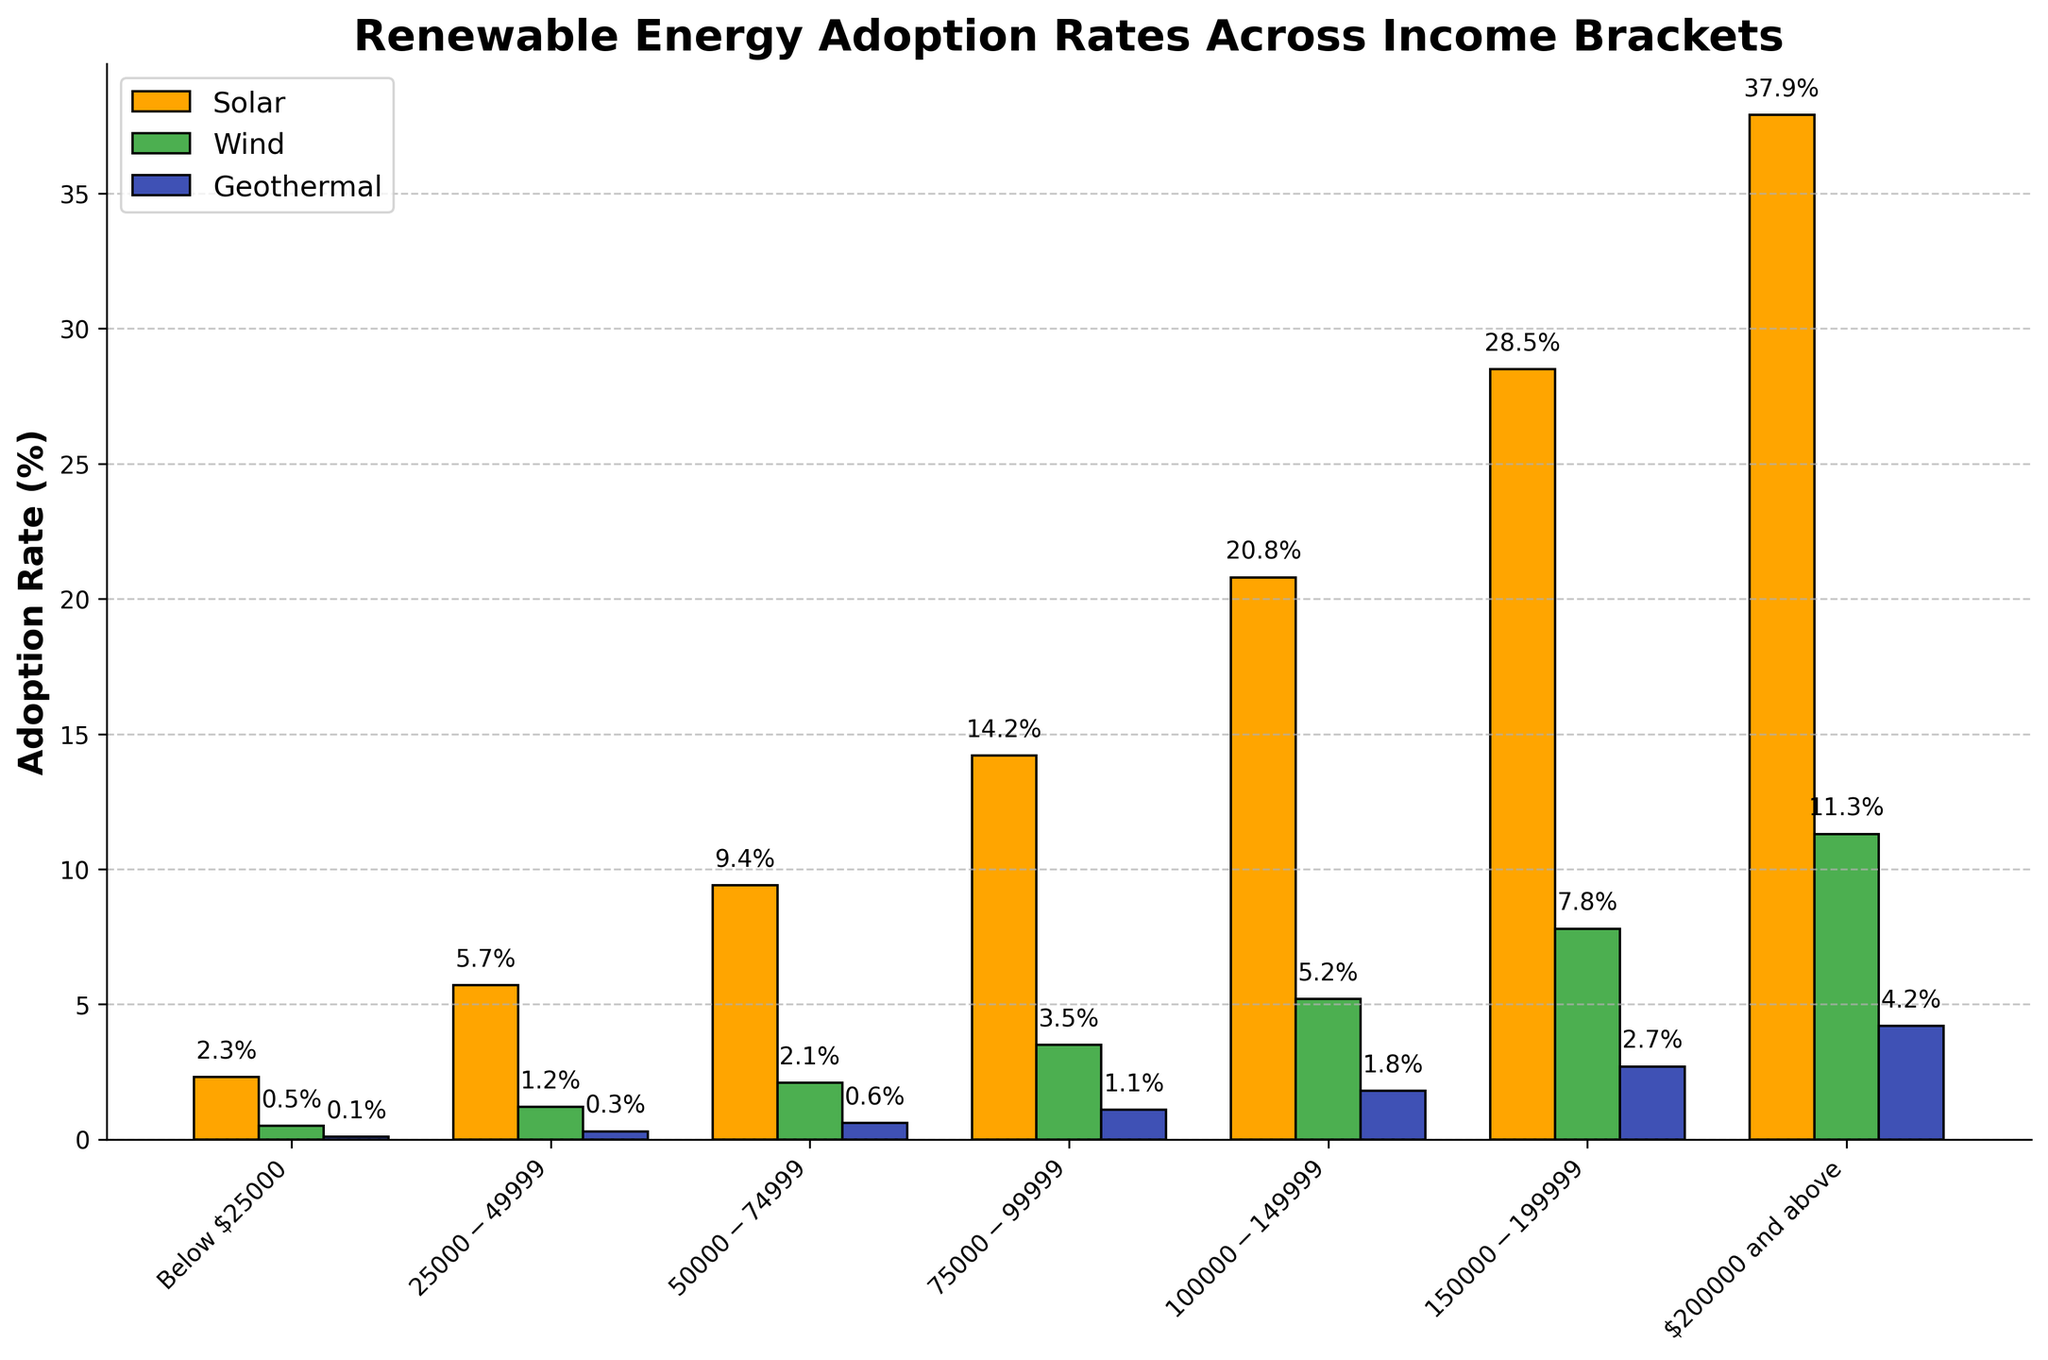Which income bracket has the highest solar adoption rate? The figure shows different bars representing solar adoption rates across various income brackets. The tallest bar in the solar category corresponds to the $200000 and above income bracket with a rate of 37.9%.
Answer: $200000 and above How does the solar adoption rate for the $75000-$99999 income bracket compare to the wind adoption rate for the same bracket? The figure displays the bars for the $75000-$99999 income bracket. The solar adoption rate bar is higher (14.2%) than the wind adoption rate bar (3.5%).
Answer: Solar is higher What is the total adoption rate for wind energy across all income brackets? To find the total wind adoption rate, sum all the wind percentages: 0.5 + 1.2 + 2.1 + 3.5 + 5.2 + 7.8 + 11.3 = 31.6%.
Answer: 31.6% Which renewable energy source has the lowest adoption rate in the $100000-$149999 income bracket? The figure shows three bars for the $100000-$149999 income bracket. The shortest bar is for geothermal with a rate of 1.8%.
Answer: Geothermal What is the difference between the solar adoption rate and the geothermal adoption rate for the $200000 and above income bracket? Refer to the figure for the $200000 and above income bracket. The solar adoption rate is 37.9% and the geothermal adoption rate is 4.2%. The difference is 37.9% - 4.2% = 33.7%.
Answer: 33.7% Which income bracket sees the most significant difference between solar and wind adoption rates? Compare the height of solar and wind bars for all income brackets. The largest difference is in the $200000 and above bracket where solar adoption is 37.9% and wind is 11.3%, with a difference of 37.9% - 11.3% = 26.6%.
Answer: $200000 and above How do the wind adoption rates for the lowest and highest income brackets compare? Review the wind adoption rates for the lowest (Below $25000) and highest ($200000 and above) income brackets. Wind adoption is 0.5% for the lowest and 11.3% for the highest bracket.
Answer: Highest is greater What is the average solar adoption rate across all income brackets? To find the average, sum all the solar adoption rates across income brackets and divide by the number of brackets: (2.3 + 5.7 + 9.4 + 14.2 + 20.8 + 28.5 + 37.9) / 7 ≈ 16.97%.
Answer: 16.97% In which income bracket is the geothermal adoption rate exactly 1.1%? The figure shows the geothermal adoption rates across income brackets. The $75000-$99999 bracket has a geothermal adoption rate of 1.1%.
Answer: $75000-$99999 What is the combined adoption rate of all renewable energy sources in the $150000-$199999 income bracket? Sum the adoption rates for solar, wind, and geothermal in the $150000-$199999 bracket: 28.5% + 7.8% + 2.7% = 39%.
Answer: 39% 